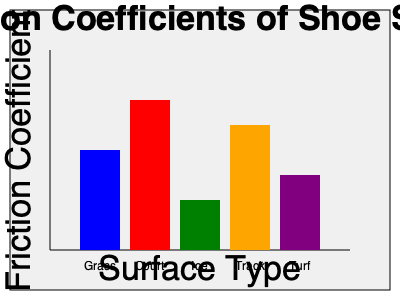Based on the graph showing friction coefficients of shoe soles on various surfaces, which surface would require a shoe sole material with the highest friction coefficient for optimal performance? To determine which surface requires a shoe sole material with the highest friction coefficient, we need to analyze the graph:

1. The y-axis represents the friction coefficient, with higher values indicating greater friction.
2. The x-axis shows different surface types: Grass, Court, Ice, Track, and Turf.
3. Each bar represents the friction coefficient for a specific surface.

Comparing the heights of the bars:
- Grass (blue): Moderate height
- Court (red): Tallest bar
- Ice (green): Shortest bar
- Track (orange): Second tallest bar
- Turf (purple): Medium height

The tallest bar corresponds to the highest friction coefficient, which is for the Court surface. This indicates that court surfaces (such as tennis or basketball courts) require shoe soles with the highest friction coefficient for optimal performance.

Higher friction is crucial on court surfaces to allow for quick starts, stops, and changes in direction without slipping. This is particularly important in sports like tennis, basketball, and volleyball, where players need excellent traction for rapid movements and precise footwork.
Answer: Court surface 